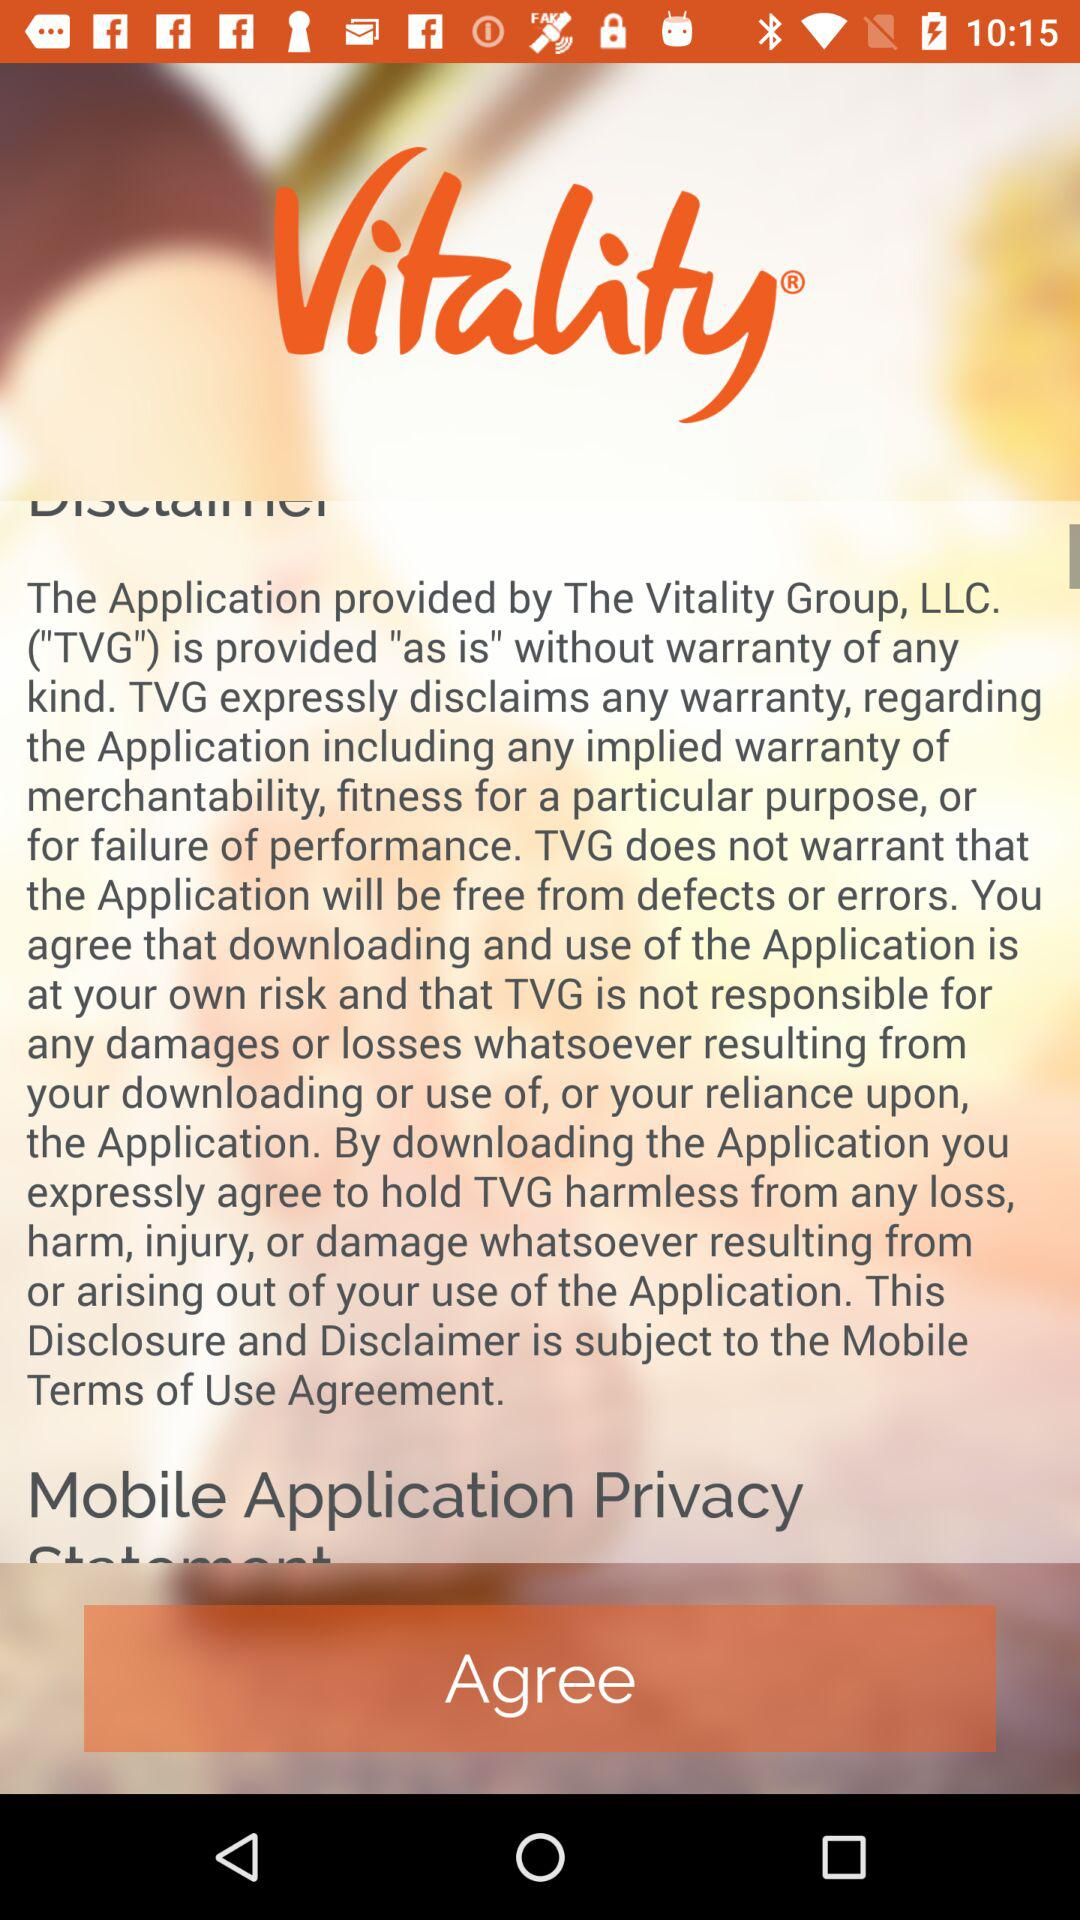What is the name of the application? The name of the application is "Vitality". 